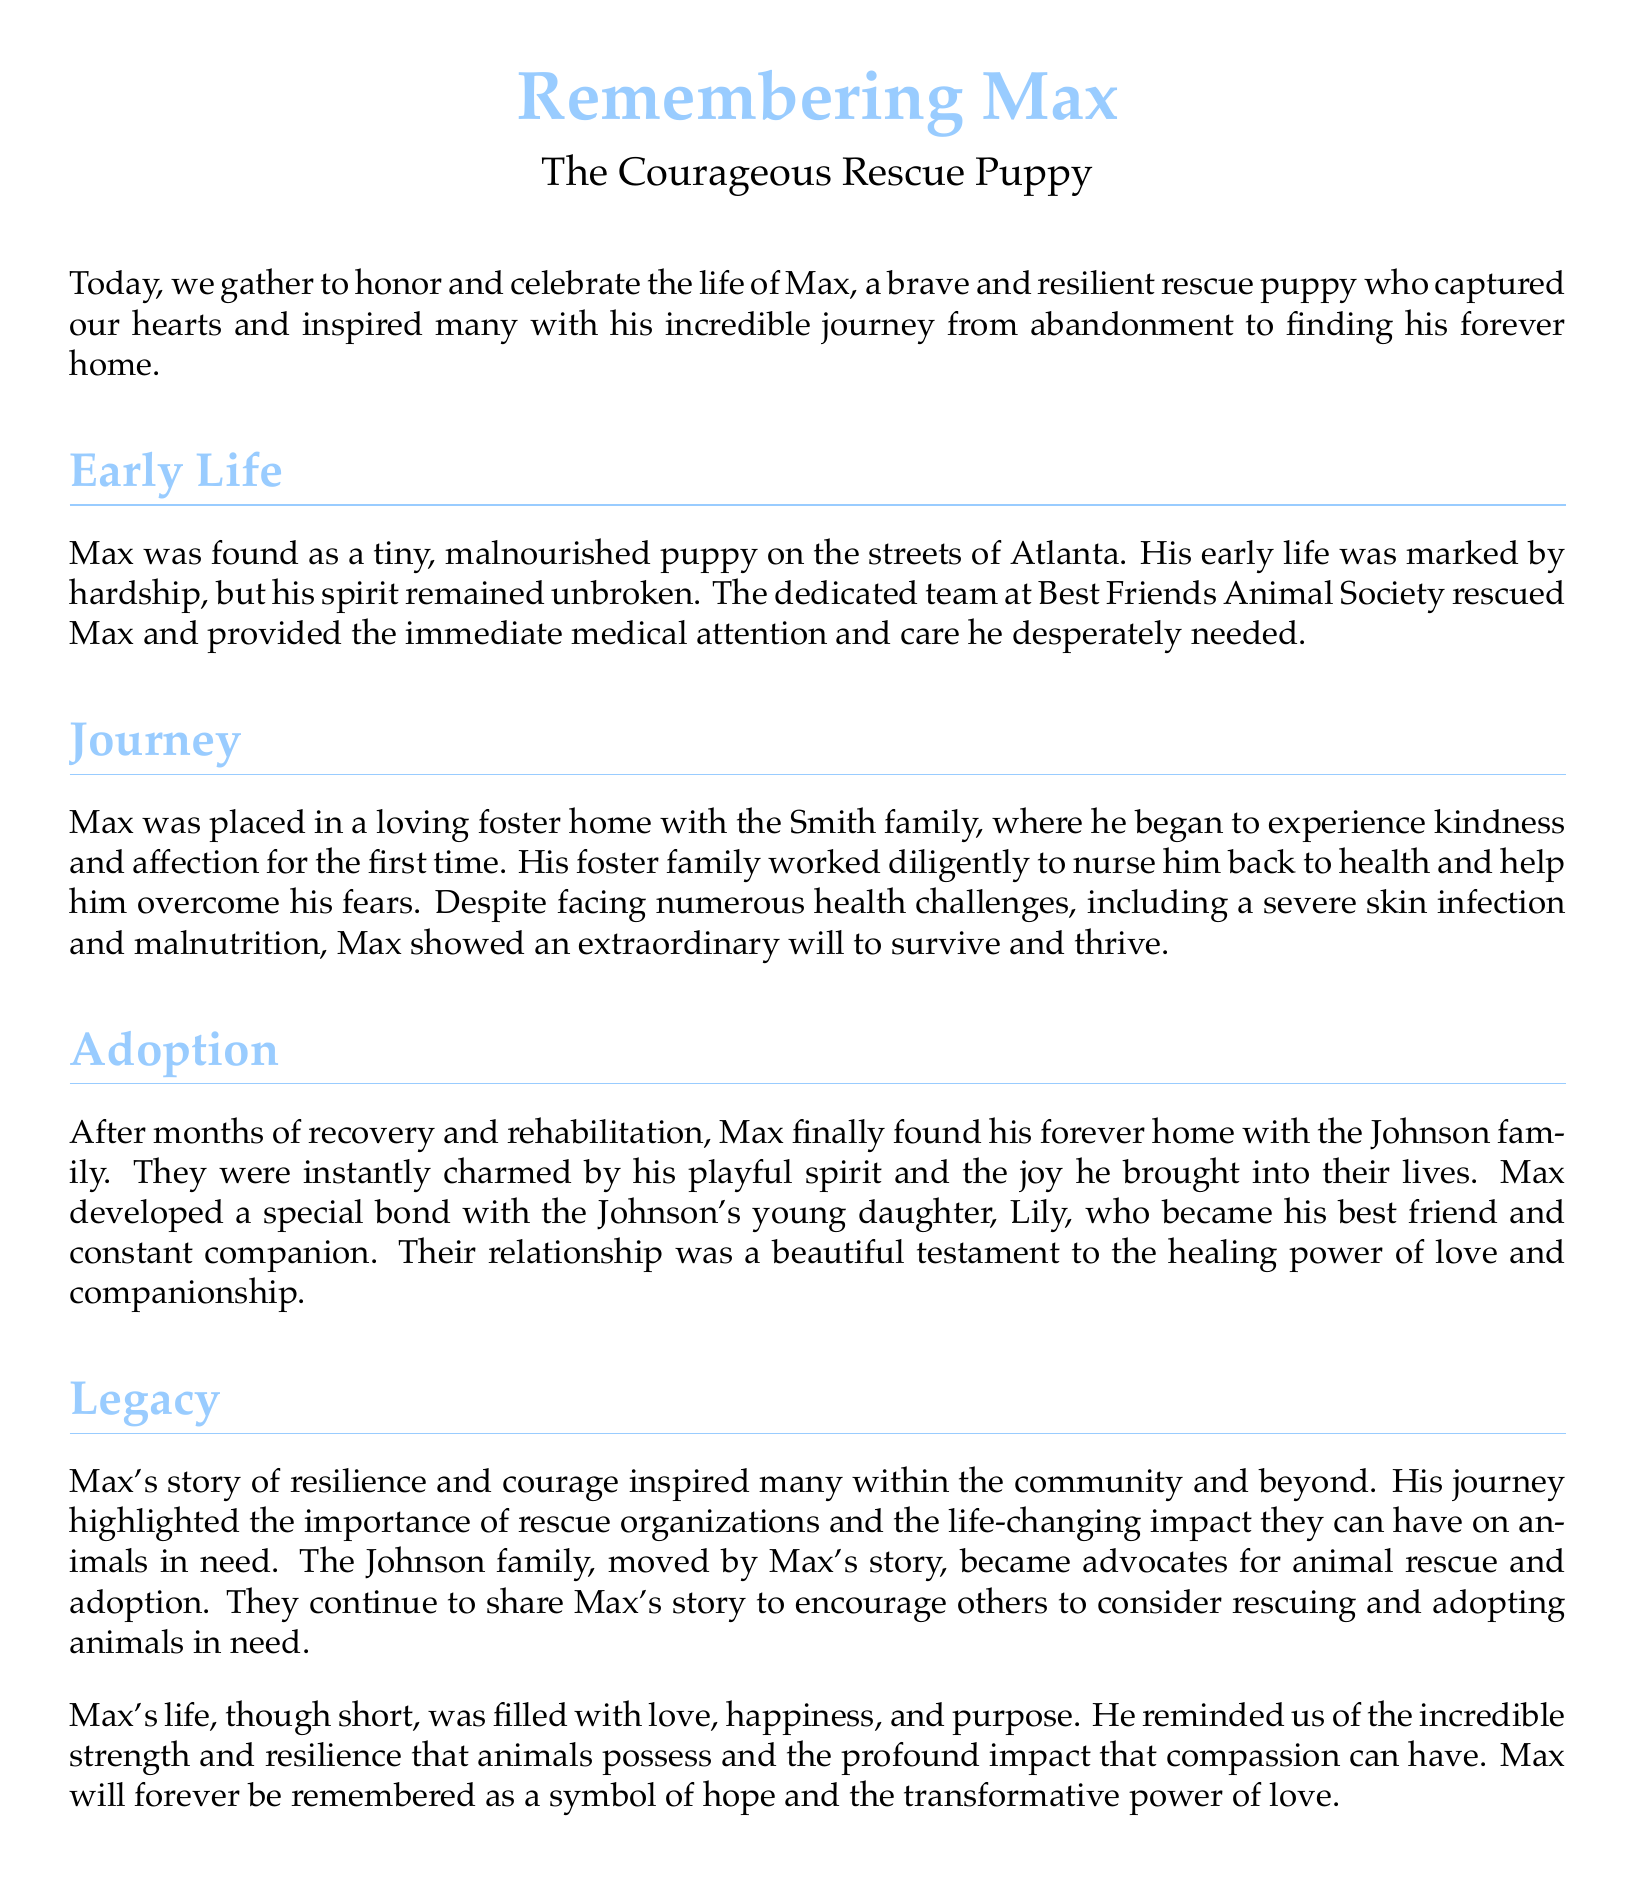What was Max? Max was a rescue puppy who was brave and resilient.
Answer: rescue puppy Where was Max found? Max was found on the streets of Atlanta.
Answer: Atlanta Who rescued Max? Max was rescued by the Best Friends Animal Society.
Answer: Best Friends Animal Society What major health challenges did Max face? Max faced a severe skin infection and malnutrition.
Answer: skin infection and malnutrition Whose family adopted Max? Max was adopted by the Johnson family.
Answer: Johnson family Who became Max's best friend? Max developed a special bond with Lily, the Johnson's young daughter.
Answer: Lily What did the Johnson family become advocates for? They became advocates for animal rescue and adoption.
Answer: animal rescue and adoption How long was Max's journey before finding a home? Max's journey included months of recovery and rehabilitation.
Answer: months What does Max's story symbolize? Max's story symbolizes hope and the transformative power of love.
Answer: hope and the transformative power of love 